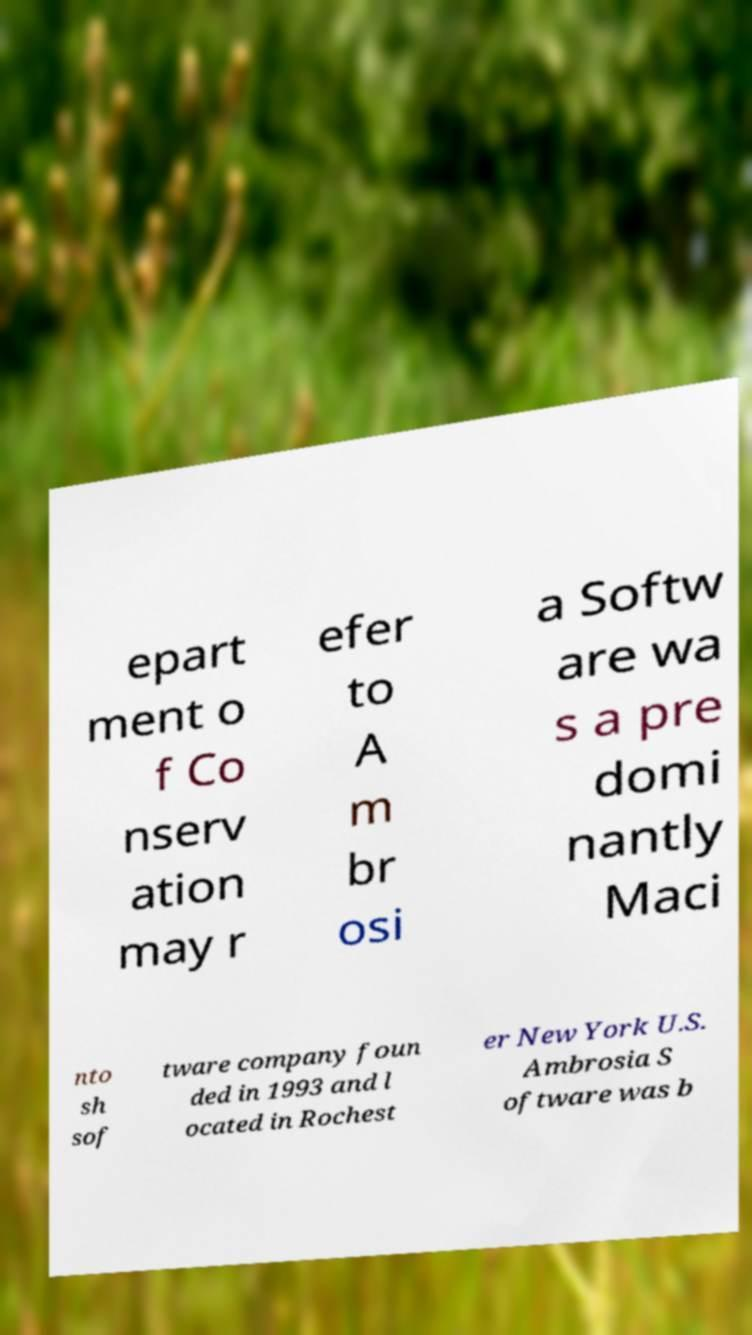Can you read and provide the text displayed in the image?This photo seems to have some interesting text. Can you extract and type it out for me? epart ment o f Co nserv ation may r efer to A m br osi a Softw are wa s a pre domi nantly Maci nto sh sof tware company foun ded in 1993 and l ocated in Rochest er New York U.S. Ambrosia S oftware was b 